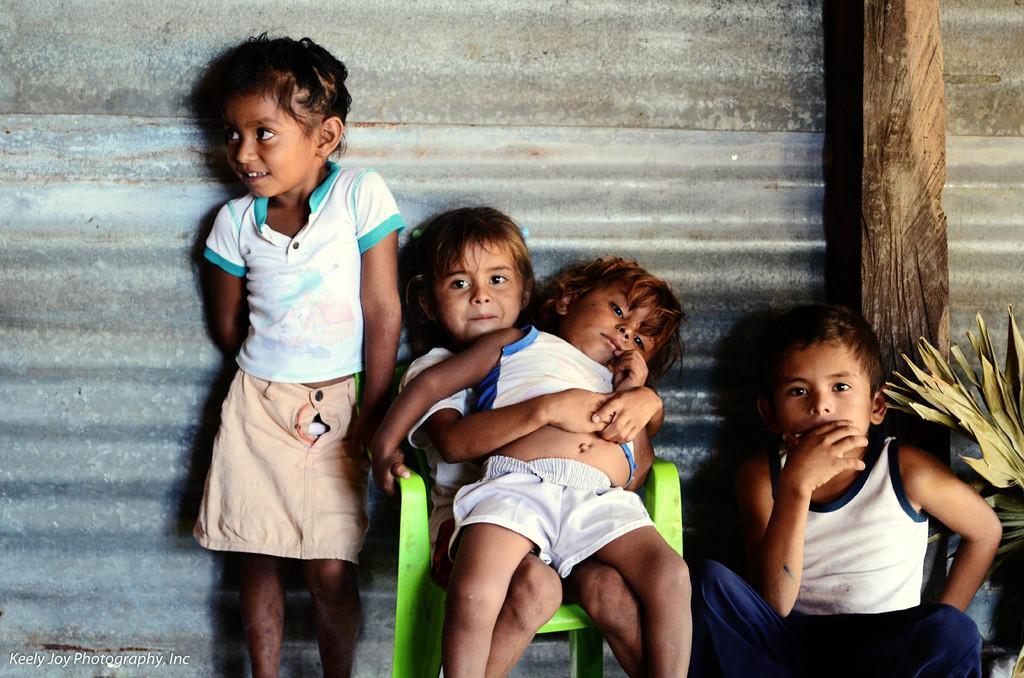Please provide a concise description of this image. In this picture we can see four kids and these two kids are sitting on the chairs. In the background we can see a metal sheet. 